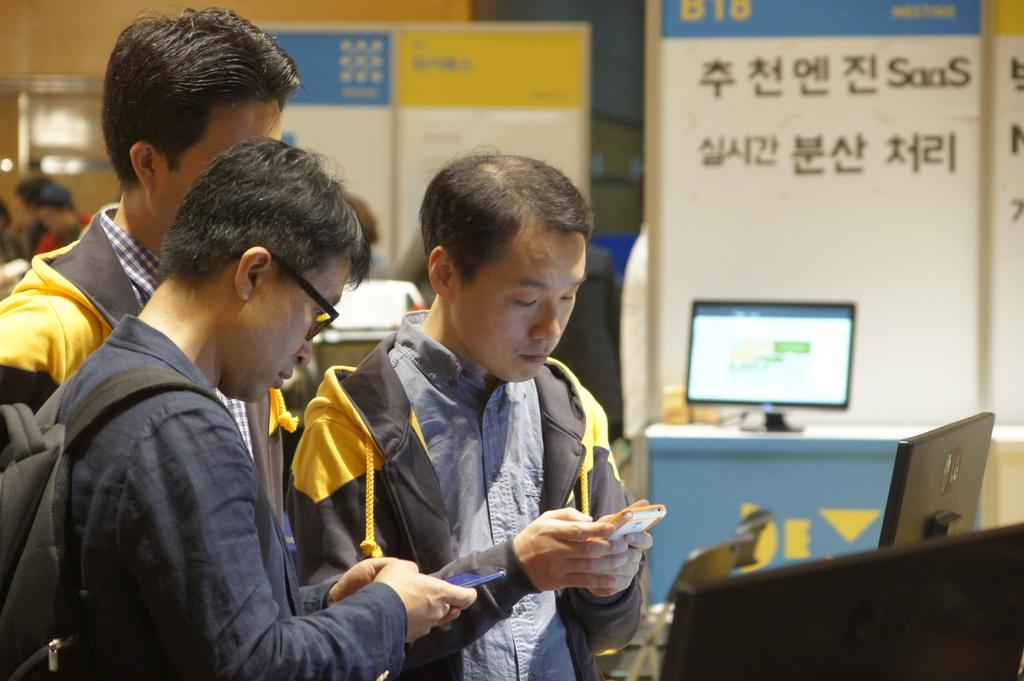How many people are in the image? There is a group of people in the image. What are two people in the group doing? Two people in the group are holding cell phones. What can be seen on the table in the image? There is a system on a table in the image. What is visible in the background of the image? There are boards with text in the background of the image. What type of balls are being used to play a game in the image? There are no balls present in the image; it features a group of people, cell phones, a system on a table, and boards with text in the background. Can you tell me how many balls of yarn are visible in the image? There are no balls of yarn present in the image. 